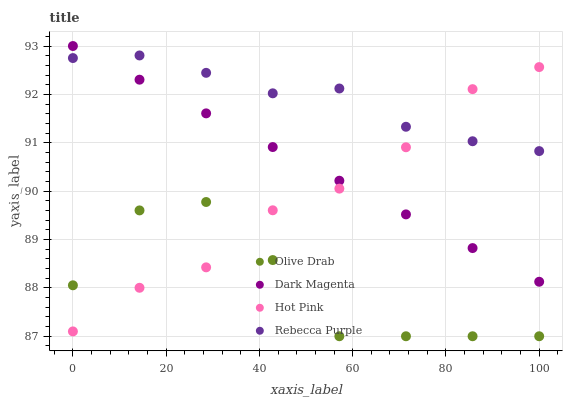Does Olive Drab have the minimum area under the curve?
Answer yes or no. Yes. Does Rebecca Purple have the maximum area under the curve?
Answer yes or no. Yes. Does Dark Magenta have the minimum area under the curve?
Answer yes or no. No. Does Dark Magenta have the maximum area under the curve?
Answer yes or no. No. Is Dark Magenta the smoothest?
Answer yes or no. Yes. Is Olive Drab the roughest?
Answer yes or no. Yes. Is Olive Drab the smoothest?
Answer yes or no. No. Is Dark Magenta the roughest?
Answer yes or no. No. Does Olive Drab have the lowest value?
Answer yes or no. Yes. Does Dark Magenta have the lowest value?
Answer yes or no. No. Does Dark Magenta have the highest value?
Answer yes or no. Yes. Does Olive Drab have the highest value?
Answer yes or no. No. Is Olive Drab less than Dark Magenta?
Answer yes or no. Yes. Is Rebecca Purple greater than Olive Drab?
Answer yes or no. Yes. Does Hot Pink intersect Dark Magenta?
Answer yes or no. Yes. Is Hot Pink less than Dark Magenta?
Answer yes or no. No. Is Hot Pink greater than Dark Magenta?
Answer yes or no. No. Does Olive Drab intersect Dark Magenta?
Answer yes or no. No. 